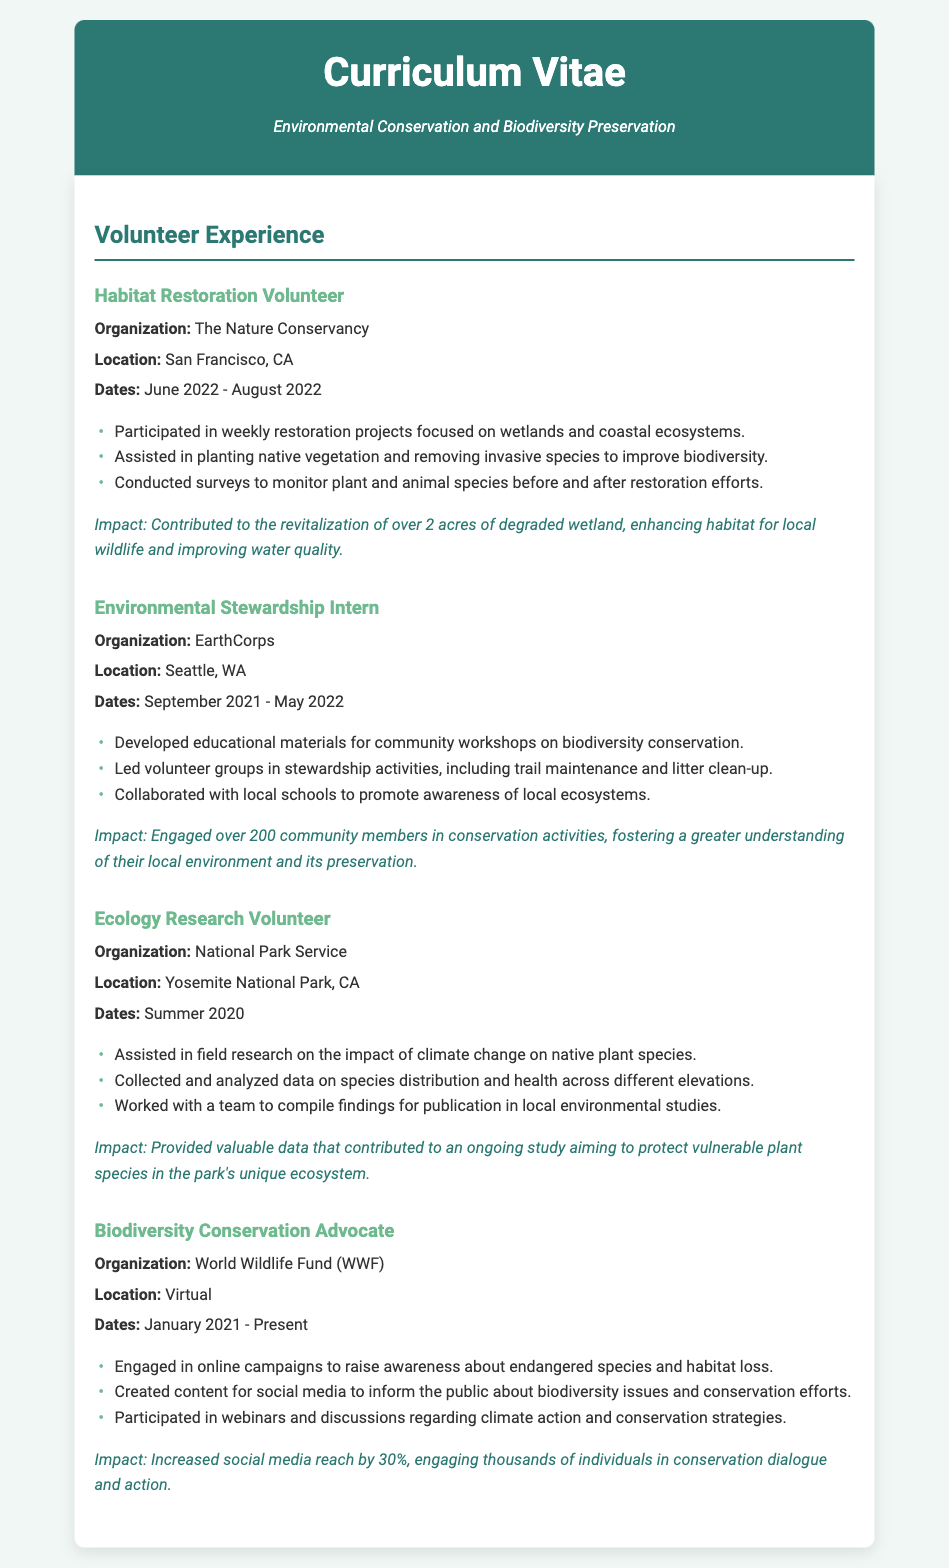What was the organization for the Habitat Restoration Volunteer position? The organization listed for this position is The Nature Conservancy.
Answer: The Nature Conservancy When did the Environmental Stewardship Intern position begin? The start date for this position is September 2021.
Answer: September 2021 How many acres were revitalized during the habitat restoration project? The document states that over 2 acres of degraded wetland were revitalized.
Answer: 2 acres What was the impact of the Biodiversity Conservation Advocate role? The impact mentioned is an increased social media reach by 30%.
Answer: 30% In which location did the Ecology Research Volunteer position take place? The location for this role is Yosemite National Park, CA.
Answer: Yosemite National Park, CA How many community members were engaged in activities through the Environmental Stewardship Intern role? The total number of engaged community members is over 200.
Answer: over 200 What type of projects did the Habitat Restoration Volunteer participate in? The document indicates that the projects focused on wetlands and coastal ecosystems.
Answer: wetlands and coastal ecosystems What did the Ecology Research Volunteer assist with? The volunteer assisted in field research on the impact of climate change on native plant species.
Answer: field research on the impact of climate change What is the current role of the Biodiversity Conservation Advocate? The current role, according to the document, is ongoing since January 2021.
Answer: Present 